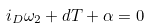Convert formula to latex. <formula><loc_0><loc_0><loc_500><loc_500>i _ { D } \omega _ { 2 } + d T + \alpha = 0</formula> 